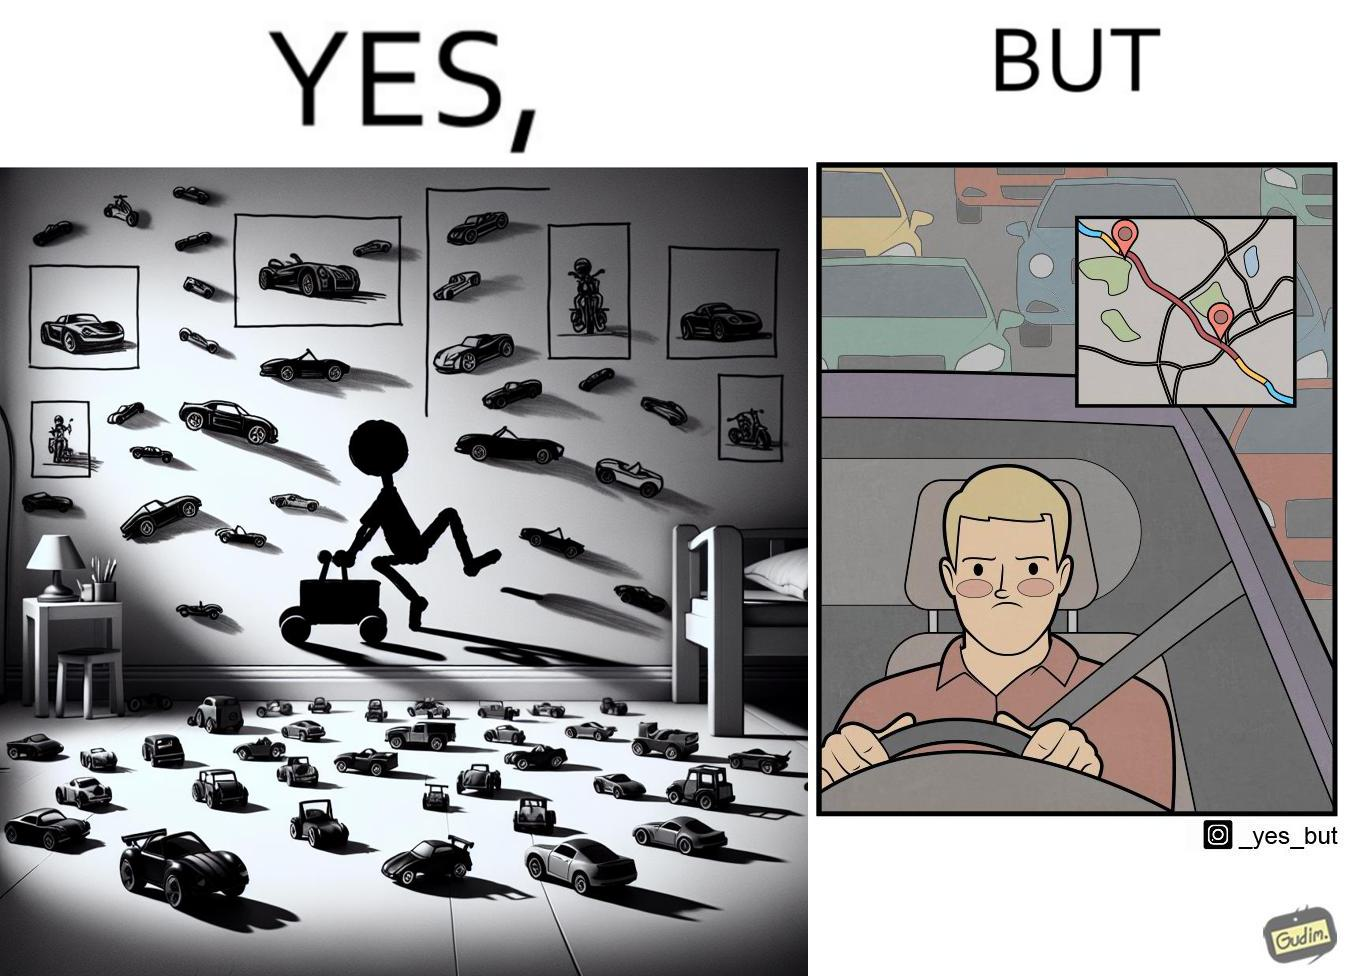Describe the contrast between the left and right parts of this image. In the left part of the image: The image shows the bedroom of a child with various small toy cars and posters of cars on the wall. The child in the picture is also riding a bigger toy car. In the right part of the image: The image shows a man annoyed by the slow traffic on his way as shown on the map while he is driving. 